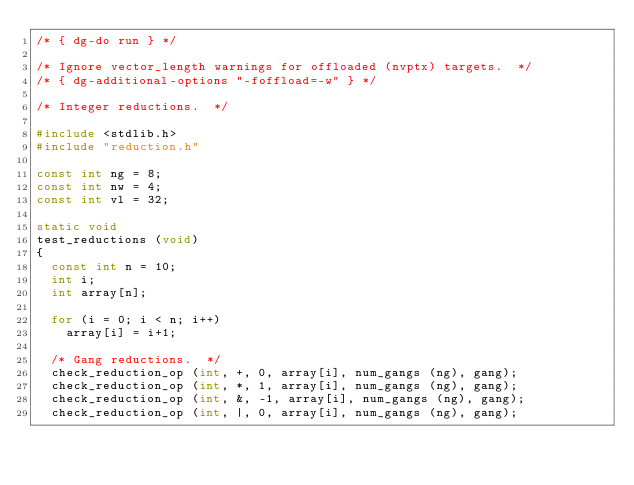<code> <loc_0><loc_0><loc_500><loc_500><_C_>/* { dg-do run } */

/* Ignore vector_length warnings for offloaded (nvptx) targets.  */
/* { dg-additional-options "-foffload=-w" } */

/* Integer reductions.  */

#include <stdlib.h>
#include "reduction.h"

const int ng = 8;
const int nw = 4;
const int vl = 32;

static void
test_reductions (void)
{
  const int n = 10;
  int i;
  int array[n];

  for (i = 0; i < n; i++)
    array[i] = i+1;

  /* Gang reductions.  */
  check_reduction_op (int, +, 0, array[i], num_gangs (ng), gang);
  check_reduction_op (int, *, 1, array[i], num_gangs (ng), gang);
  check_reduction_op (int, &, -1, array[i], num_gangs (ng), gang);
  check_reduction_op (int, |, 0, array[i], num_gangs (ng), gang);</code> 